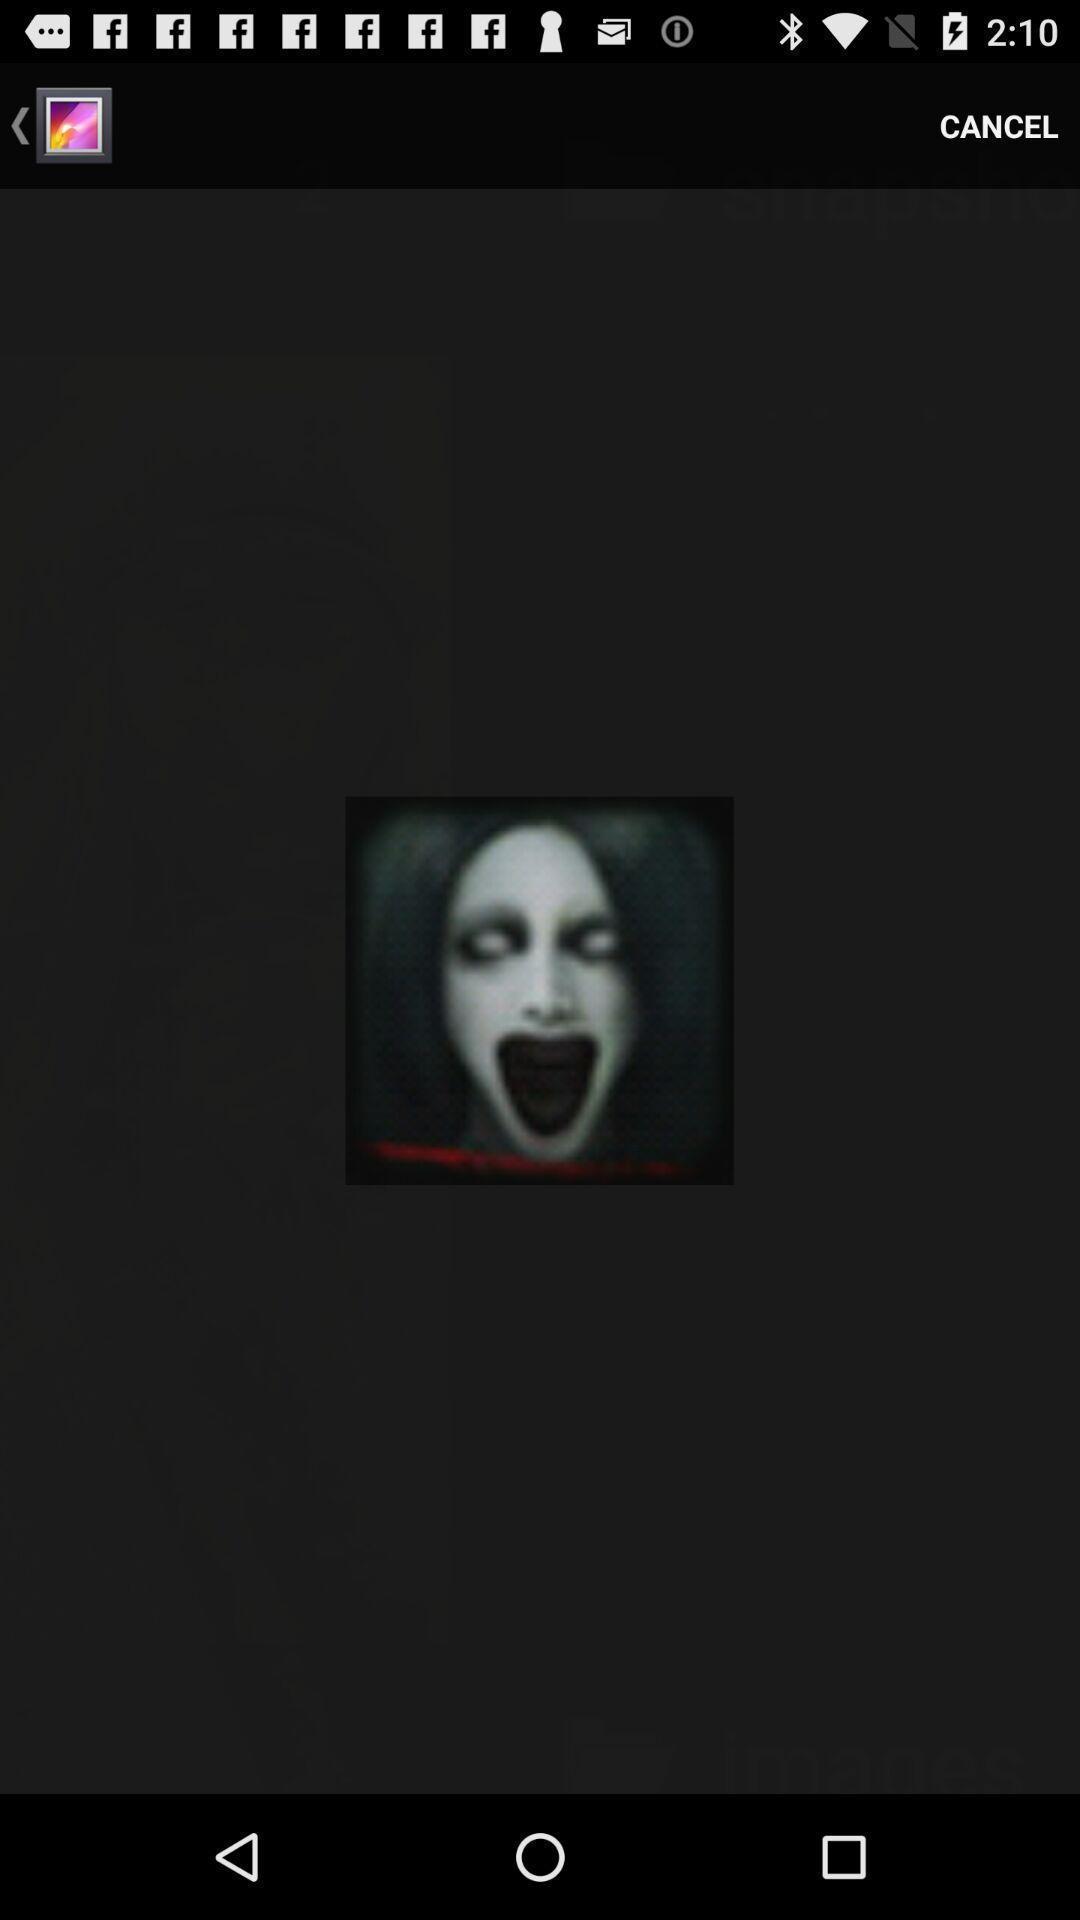Give me a summary of this screen capture. Screen displaying an image. 